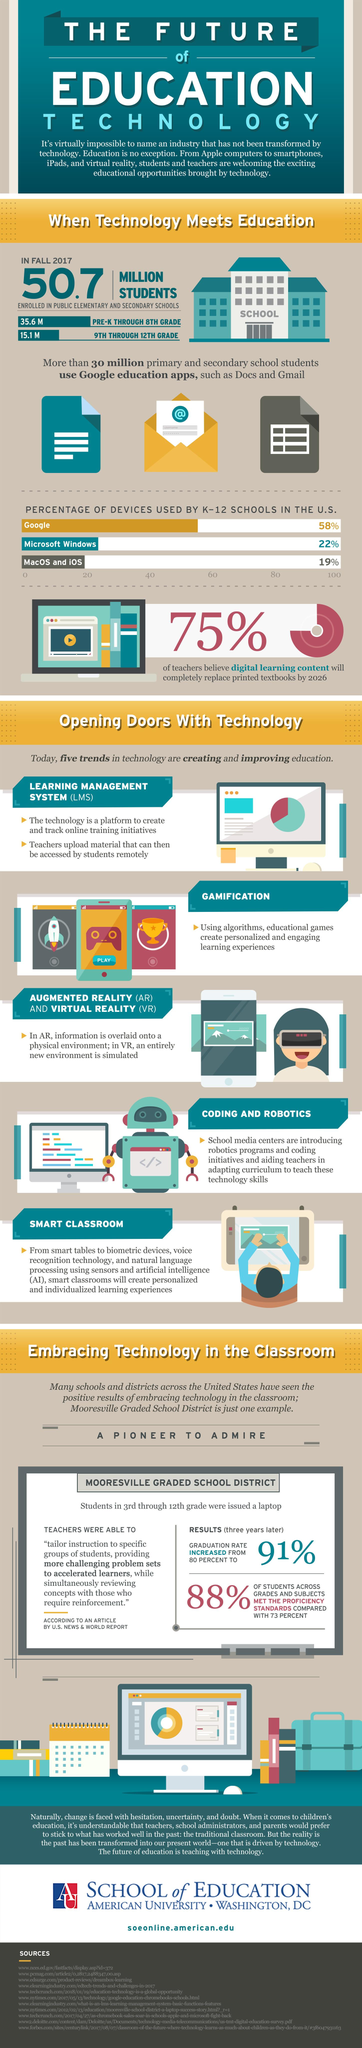Specify some key components in this picture. Google is the device that is most widely used by K-12 schools in the United States. According to a recent study, a significant percentage of K-12 schools in the U.S. are currently using Google devices as their primary educational technology tools. Specifically, 58% of K-12 schools in the U.S. have adopted Google devices for educational purposes. According to a recent study, K-12 schools in the United States use MacOS and iOS as a combined percentage of 19%. In the United States, K-12 schools use MacOS and iOS the least among all devices. In the fall of 2017, there were a total of 50.7 million students enrolled in public elementary and secondary schools in the United States. 